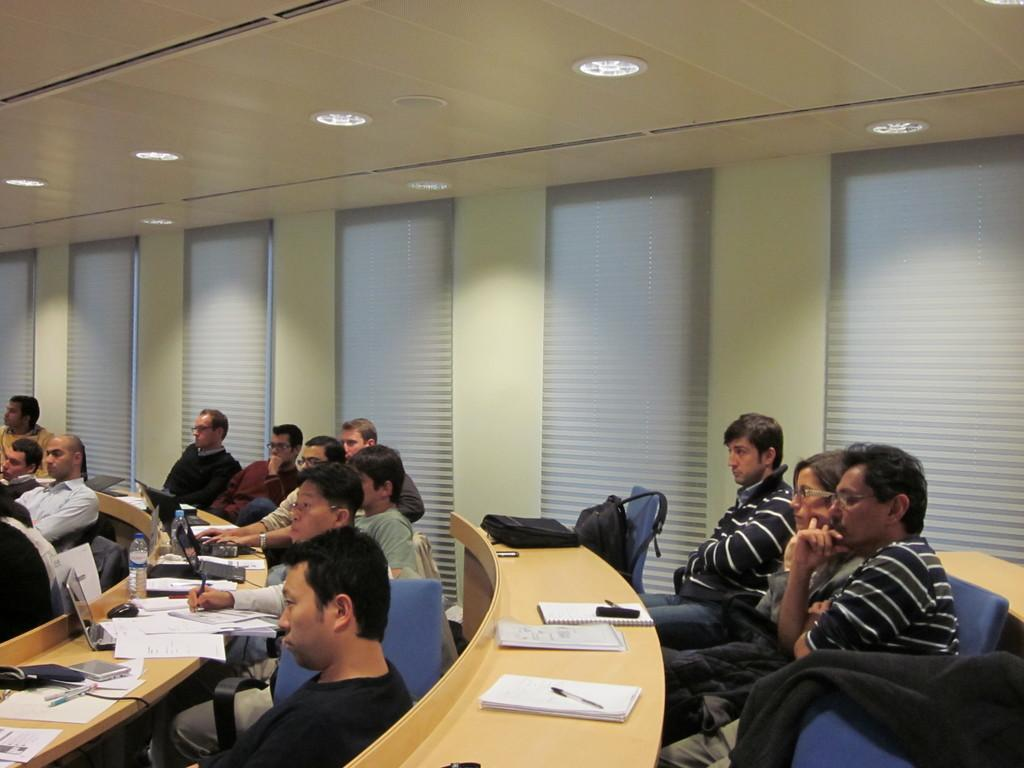How many people are in the image? There is a group of persons in the image. What are the persons doing in the image? The persons are sitting in chairs. What is in front of the group of persons? There is a table in front of the group of persons. What items can be seen on the table? There are books and laptops on the table. What type of stitch is being used by the carpenter in the image? There is no carpenter or stitching activity present in the image. What type of slip is visible on the person sitting on the left side of the image? There is no slip visible on any person in the image. 